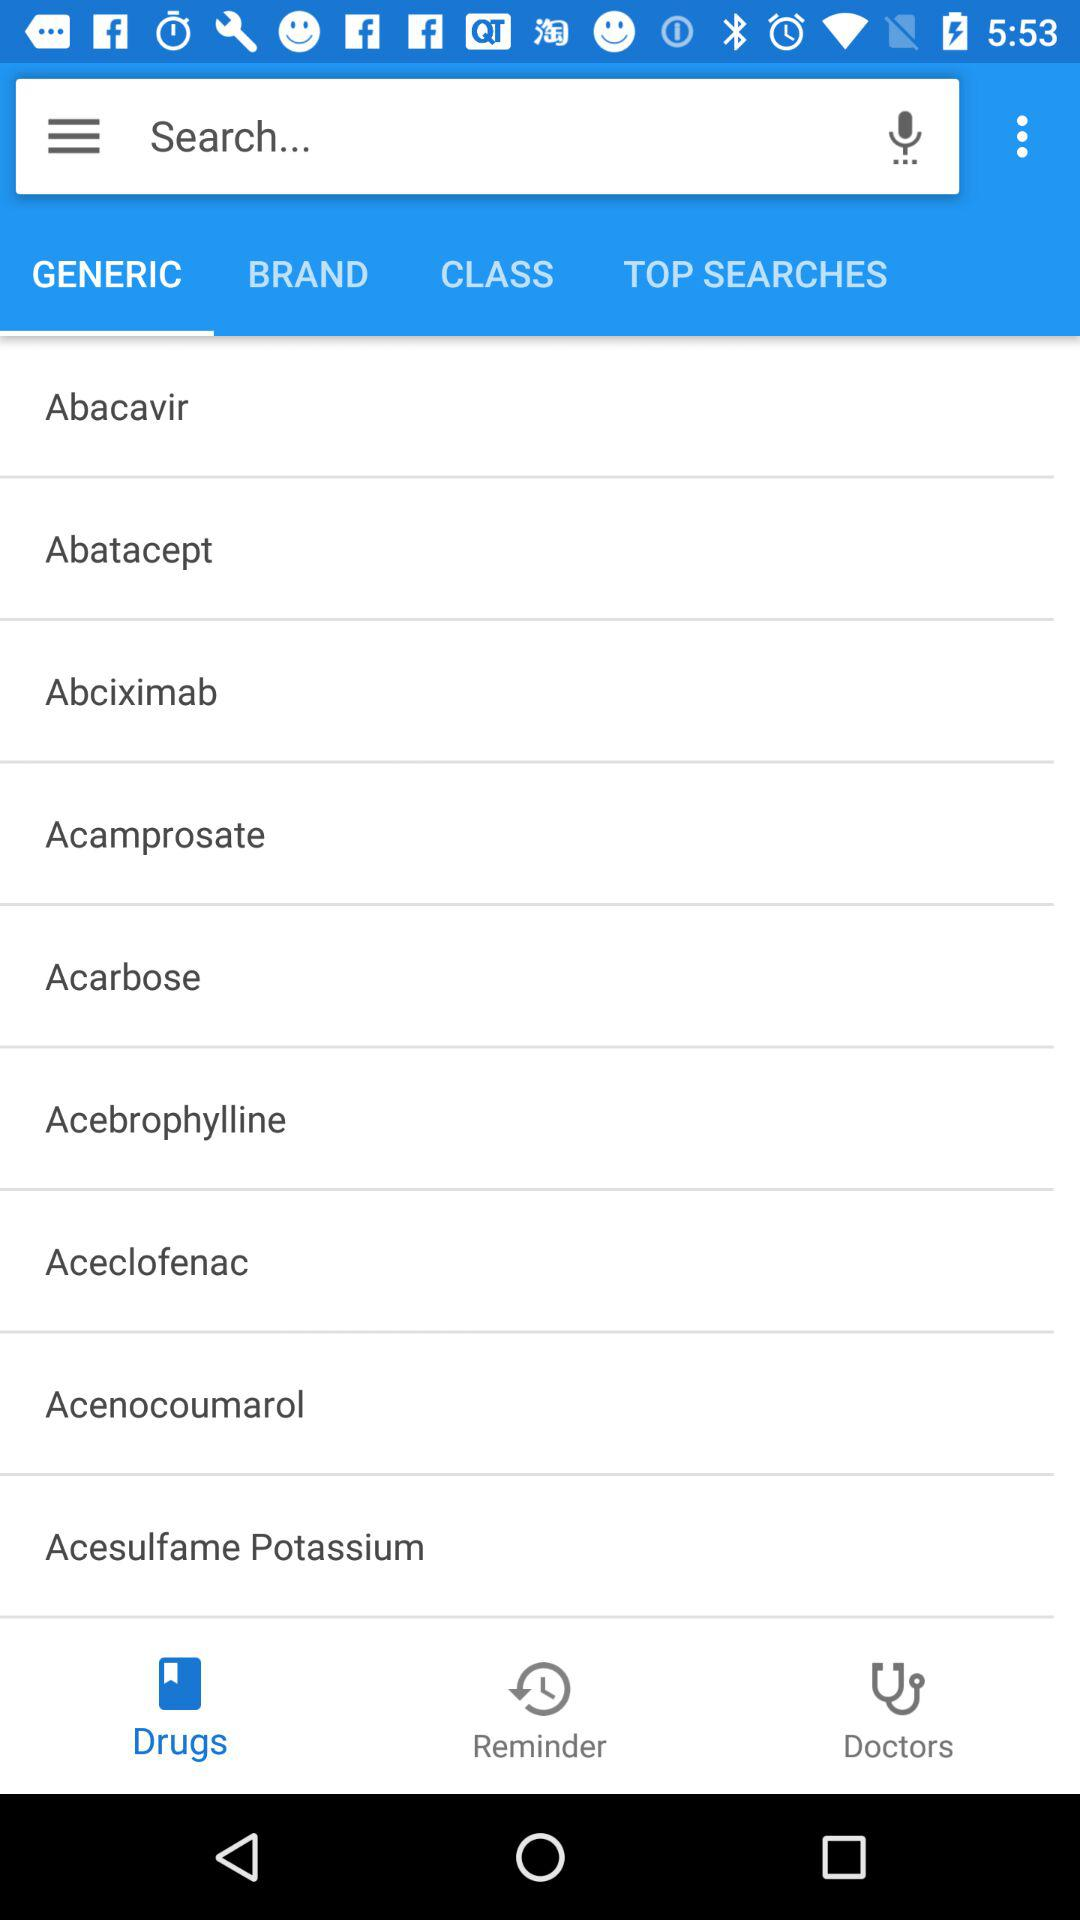Which tab is selected? The selected tab is Generic. 